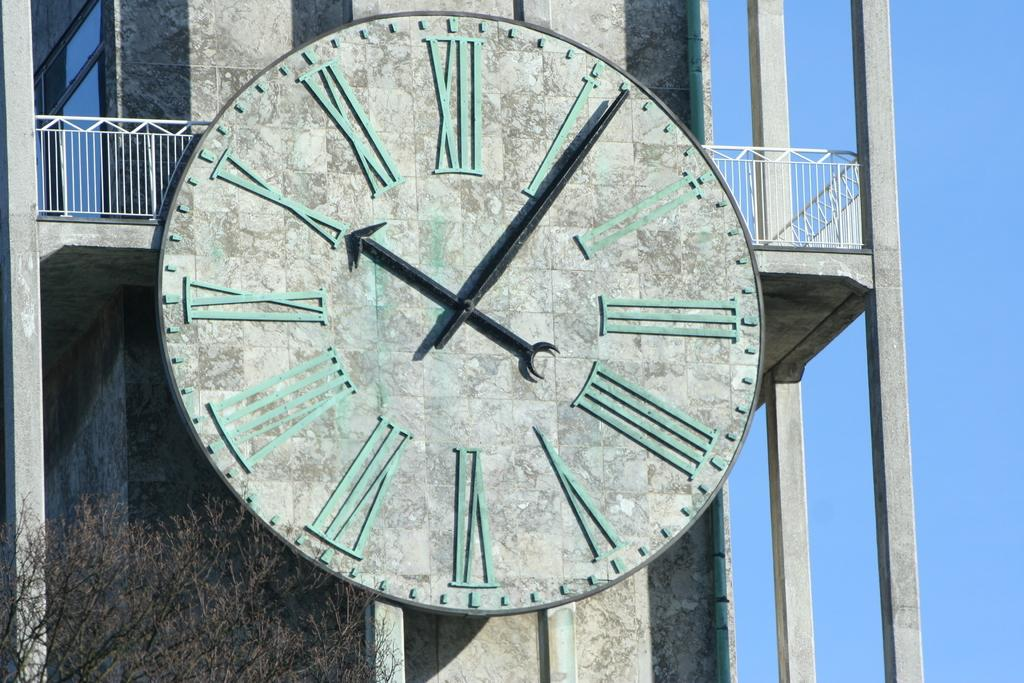What is on the building in the image? There is a clock on a building in the image. What type of plant can be seen in the image? There is a tree in the image. What type of dress is the tree wearing in the image? There is no dress present in the image, as trees do not wear clothing. 